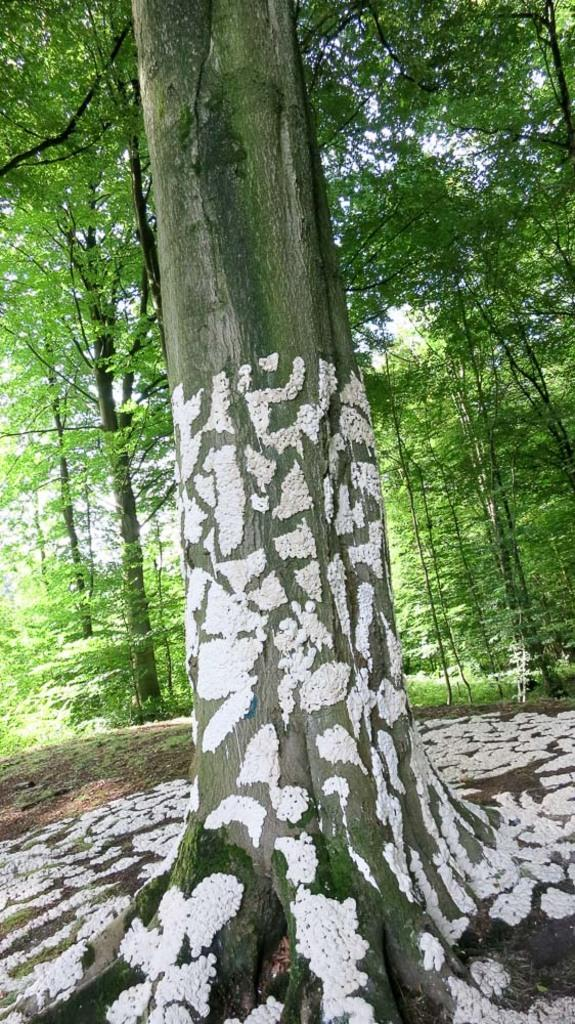What is the main subject of the image? The main subject of the image is a tree with white color patches on its trunk and roots. What can be seen in the background of the image? In the background of the image, there are trees and the sky. What type of industry can be seen in the image? There is no industry present in the image; it features a tree with white color patches on its trunk and roots, along with trees and the sky in the background. Can you describe the care and kissing scene between the two people in the image? There are no people present in the image, and therefore no care or kissing scene can be observed. 